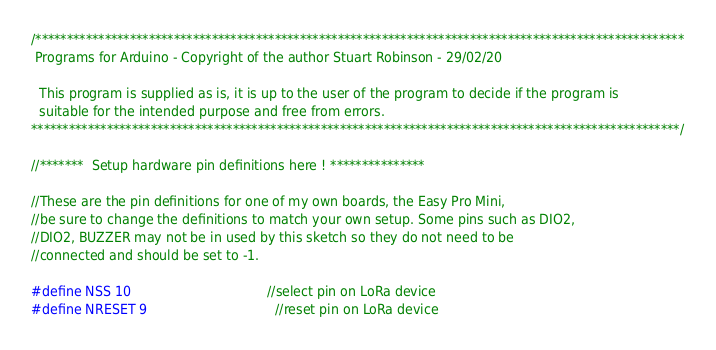Convert code to text. <code><loc_0><loc_0><loc_500><loc_500><_C_>/*******************************************************************************************************
 Programs for Arduino - Copyright of the author Stuart Robinson - 29/02/20

  This program is supplied as is, it is up to the user of the program to decide if the program is
  suitable for the intended purpose and free from errors.
*******************************************************************************************************/

//*******  Setup hardware pin definitions here ! ***************

//These are the pin definitions for one of my own boards, the Easy Pro Mini,
//be sure to change the definitions to match your own setup. Some pins such as DIO2,
//DIO2, BUZZER may not be in used by this sketch so they do not need to be
//connected and should be set to -1.

#define NSS 10                                  //select pin on LoRa device
#define NRESET 9                                //reset pin on LoRa device</code> 